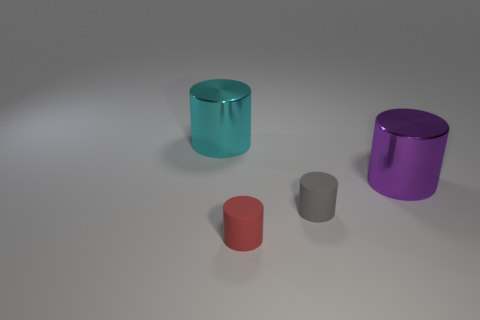What size is the red thing that is the same shape as the gray matte object?
Offer a very short reply. Small. What color is the cylinder that is both behind the tiny gray rubber cylinder and in front of the cyan object?
Your response must be concise. Purple. How many things are large objects that are to the left of the tiny red cylinder or yellow matte cubes?
Give a very brief answer. 1. There is another metal thing that is the same shape as the big purple shiny thing; what is its color?
Provide a short and direct response. Cyan. There is a tiny gray object; does it have the same shape as the shiny thing that is on the right side of the gray matte cylinder?
Your answer should be compact. Yes. How many objects are either shiny cylinders that are behind the purple thing or large shiny cylinders behind the purple thing?
Ensure brevity in your answer.  1. Are there fewer cyan shiny cylinders that are on the left side of the small gray object than large purple cylinders?
Offer a terse response. No. Does the cyan cylinder have the same material as the large cylinder that is to the right of the red matte object?
Provide a short and direct response. Yes. What material is the cyan cylinder?
Provide a short and direct response. Metal. There is a cylinder that is behind the big cylinder that is in front of the metal thing on the left side of the large purple shiny cylinder; what is its material?
Provide a succinct answer. Metal. 